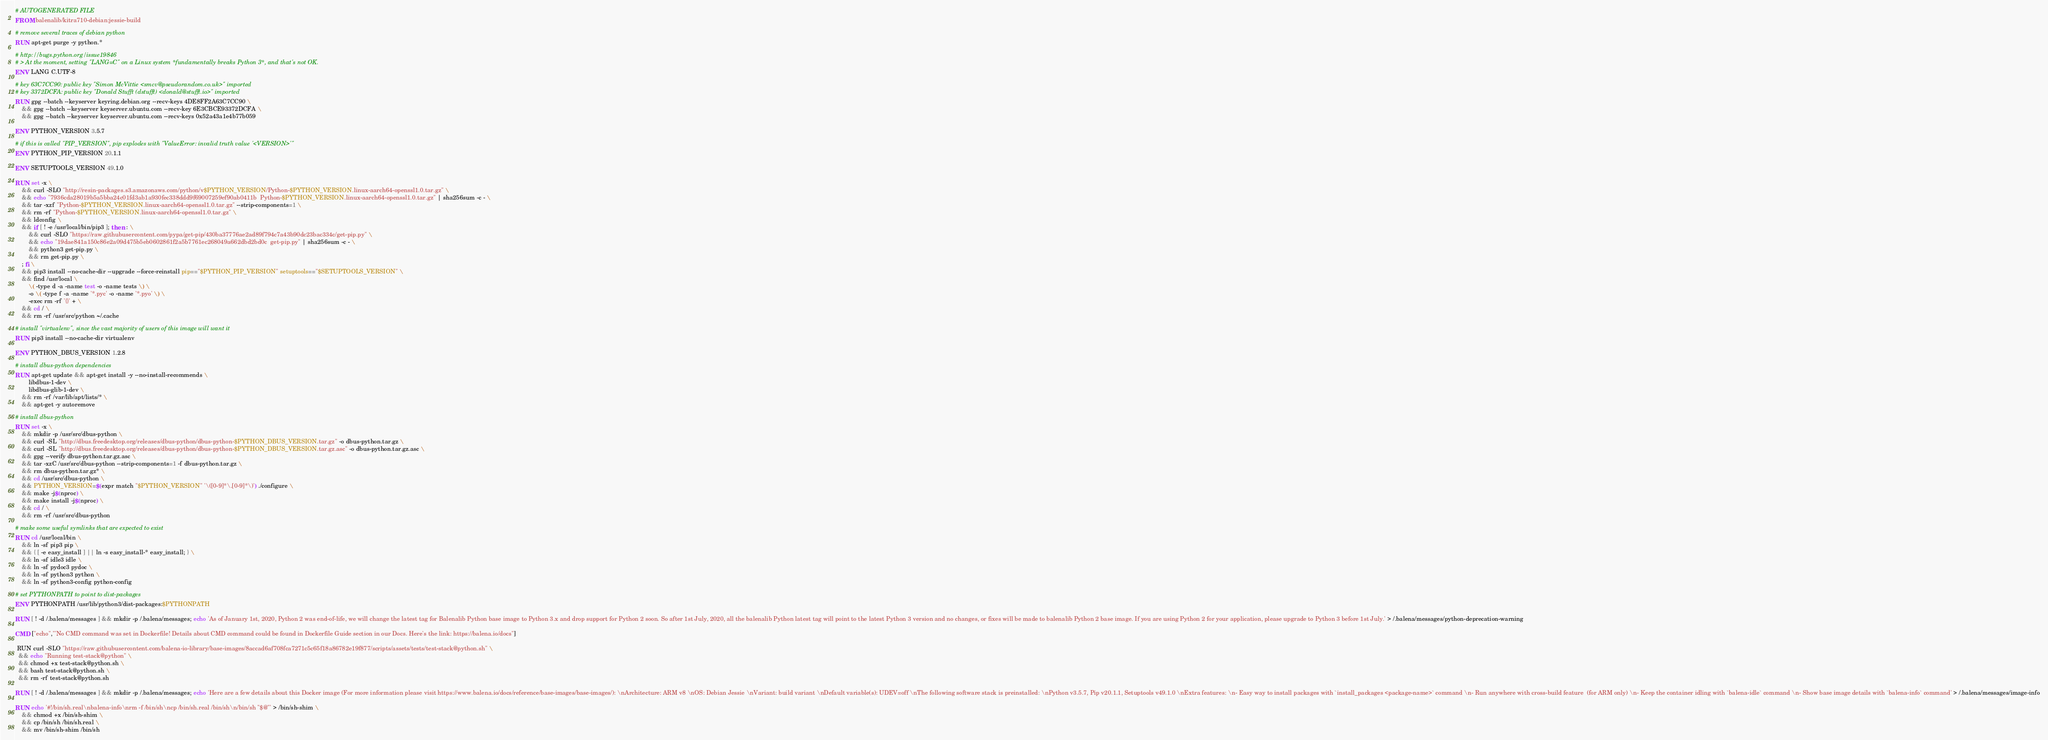Convert code to text. <code><loc_0><loc_0><loc_500><loc_500><_Dockerfile_># AUTOGENERATED FILE
FROM balenalib/kitra710-debian:jessie-build

# remove several traces of debian python
RUN apt-get purge -y python.*

# http://bugs.python.org/issue19846
# > At the moment, setting "LANG=C" on a Linux system *fundamentally breaks Python 3*, and that's not OK.
ENV LANG C.UTF-8

# key 63C7CC90: public key "Simon McVittie <smcv@pseudorandom.co.uk>" imported
# key 3372DCFA: public key "Donald Stufft (dstufft) <donald@stufft.io>" imported
RUN gpg --batch --keyserver keyring.debian.org --recv-keys 4DE8FF2A63C7CC90 \
	&& gpg --batch --keyserver keyserver.ubuntu.com --recv-key 6E3CBCE93372DCFA \
	&& gpg --batch --keyserver keyserver.ubuntu.com --recv-keys 0x52a43a1e4b77b059

ENV PYTHON_VERSION 3.5.7

# if this is called "PIP_VERSION", pip explodes with "ValueError: invalid truth value '<VERSION>'"
ENV PYTHON_PIP_VERSION 20.1.1

ENV SETUPTOOLS_VERSION 49.1.0

RUN set -x \
	&& curl -SLO "http://resin-packages.s3.amazonaws.com/python/v$PYTHON_VERSION/Python-$PYTHON_VERSION.linux-aarch64-openssl1.0.tar.gz" \
	&& echo "7936cda28019b5a5bba24c01fd3ab1a930fec338ddd9f69007259ef90ab0411b  Python-$PYTHON_VERSION.linux-aarch64-openssl1.0.tar.gz" | sha256sum -c - \
	&& tar -xzf "Python-$PYTHON_VERSION.linux-aarch64-openssl1.0.tar.gz" --strip-components=1 \
	&& rm -rf "Python-$PYTHON_VERSION.linux-aarch64-openssl1.0.tar.gz" \
	&& ldconfig \
	&& if [ ! -e /usr/local/bin/pip3 ]; then : \
		&& curl -SLO "https://raw.githubusercontent.com/pypa/get-pip/430ba37776ae2ad89f794c7a43b90dc23bac334c/get-pip.py" \
		&& echo "19dae841a150c86e2a09d475b5eb0602861f2a5b7761ec268049a662dbd2bd0c  get-pip.py" | sha256sum -c - \
		&& python3 get-pip.py \
		&& rm get-pip.py \
	; fi \
	&& pip3 install --no-cache-dir --upgrade --force-reinstall pip=="$PYTHON_PIP_VERSION" setuptools=="$SETUPTOOLS_VERSION" \
	&& find /usr/local \
		\( -type d -a -name test -o -name tests \) \
		-o \( -type f -a -name '*.pyc' -o -name '*.pyo' \) \
		-exec rm -rf '{}' + \
	&& cd / \
	&& rm -rf /usr/src/python ~/.cache

# install "virtualenv", since the vast majority of users of this image will want it
RUN pip3 install --no-cache-dir virtualenv

ENV PYTHON_DBUS_VERSION 1.2.8

# install dbus-python dependencies 
RUN apt-get update && apt-get install -y --no-install-recommends \
		libdbus-1-dev \
		libdbus-glib-1-dev \
	&& rm -rf /var/lib/apt/lists/* \
	&& apt-get -y autoremove

# install dbus-python
RUN set -x \
	&& mkdir -p /usr/src/dbus-python \
	&& curl -SL "http://dbus.freedesktop.org/releases/dbus-python/dbus-python-$PYTHON_DBUS_VERSION.tar.gz" -o dbus-python.tar.gz \
	&& curl -SL "http://dbus.freedesktop.org/releases/dbus-python/dbus-python-$PYTHON_DBUS_VERSION.tar.gz.asc" -o dbus-python.tar.gz.asc \
	&& gpg --verify dbus-python.tar.gz.asc \
	&& tar -xzC /usr/src/dbus-python --strip-components=1 -f dbus-python.tar.gz \
	&& rm dbus-python.tar.gz* \
	&& cd /usr/src/dbus-python \
	&& PYTHON_VERSION=$(expr match "$PYTHON_VERSION" '\([0-9]*\.[0-9]*\)') ./configure \
	&& make -j$(nproc) \
	&& make install -j$(nproc) \
	&& cd / \
	&& rm -rf /usr/src/dbus-python

# make some useful symlinks that are expected to exist
RUN cd /usr/local/bin \
	&& ln -sf pip3 pip \
	&& { [ -e easy_install ] || ln -s easy_install-* easy_install; } \
	&& ln -sf idle3 idle \
	&& ln -sf pydoc3 pydoc \
	&& ln -sf python3 python \
	&& ln -sf python3-config python-config

# set PYTHONPATH to point to dist-packages
ENV PYTHONPATH /usr/lib/python3/dist-packages:$PYTHONPATH

RUN [ ! -d /.balena/messages ] && mkdir -p /.balena/messages; echo 'As of January 1st, 2020, Python 2 was end-of-life, we will change the latest tag for Balenalib Python base image to Python 3.x and drop support for Python 2 soon. So after 1st July, 2020, all the balenalib Python latest tag will point to the latest Python 3 version and no changes, or fixes will be made to balenalib Python 2 base image. If you are using Python 2 for your application, please upgrade to Python 3 before 1st July.' > /.balena/messages/python-deprecation-warning

CMD ["echo","'No CMD command was set in Dockerfile! Details about CMD command could be found in Dockerfile Guide section in our Docs. Here's the link: https://balena.io/docs"]

 RUN curl -SLO "https://raw.githubusercontent.com/balena-io-library/base-images/8accad6af708fca7271c5c65f18a86782e19f877/scripts/assets/tests/test-stack@python.sh" \
  && echo "Running test-stack@python" \
  && chmod +x test-stack@python.sh \
  && bash test-stack@python.sh \
  && rm -rf test-stack@python.sh 

RUN [ ! -d /.balena/messages ] && mkdir -p /.balena/messages; echo 'Here are a few details about this Docker image (For more information please visit https://www.balena.io/docs/reference/base-images/base-images/): \nArchitecture: ARM v8 \nOS: Debian Jessie \nVariant: build variant \nDefault variable(s): UDEV=off \nThe following software stack is preinstalled: \nPython v3.5.7, Pip v20.1.1, Setuptools v49.1.0 \nExtra features: \n- Easy way to install packages with `install_packages <package-name>` command \n- Run anywhere with cross-build feature  (for ARM only) \n- Keep the container idling with `balena-idle` command \n- Show base image details with `balena-info` command' > /.balena/messages/image-info

RUN echo '#!/bin/sh.real\nbalena-info\nrm -f /bin/sh\ncp /bin/sh.real /bin/sh\n/bin/sh "$@"' > /bin/sh-shim \
	&& chmod +x /bin/sh-shim \
	&& cp /bin/sh /bin/sh.real \
	&& mv /bin/sh-shim /bin/sh</code> 